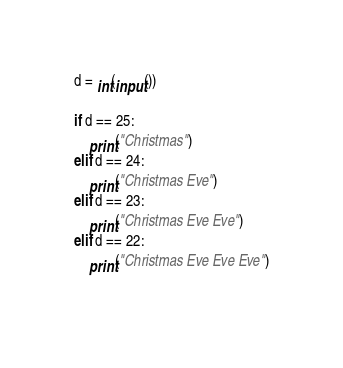Convert code to text. <code><loc_0><loc_0><loc_500><loc_500><_Python_>d = int(input())

if d == 25:
    print("Christmas")
elif d == 24:
    print("Christmas Eve")
elif d == 23:
    print("Christmas Eve Eve")
elif d == 22:
    print("Christmas Eve Eve Eve")
    </code> 